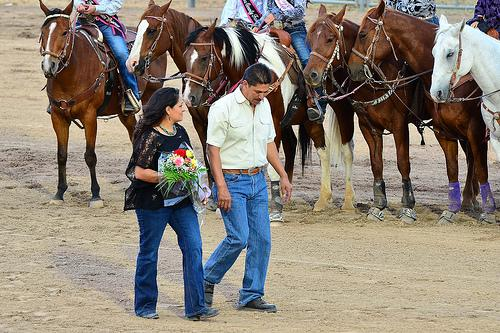Provide a brief caption for this image. A couple walking with a flower bouquet near a line of standing horses on a sandy ground. Count the number of horses in the image. There are six horses in the image. What emotions or sentiments can you identify from the image? The image evokes a sense of tranquility and harmony, as the couple and the horses are peacefully interacting in a natural environment. Describe the ground surface in the image. The ground surface is sandy and brown in color, with visible footprints and horse tracks. Mention the details of the woman's clothing and accessories. The woman is wearing a black shirt, blue jeans, a necklace, and earrings while carrying a colorful flower bouquet. Analyze the interaction between the people and the horses. The people and horses coexist peacefully, with the couple walking by the line of standing horses without interrupting or disturbing them. Describe the colors of the horses. The horses are predominantly brown and white. What are the two people in the foreground wearing, and what are they doing? A woman is wearing a black blouse and blue jeans, carrying a bouquet of flowers, while a man is wearing a white shirt, blue jeans, and a brown belt; both are walking amid horses. What types of clothing and accessories are visible on the man in the image? The man is wearing a white shirt, a brown belt, light blue jeans, and possibly black shoes. What objects are in the image? Horses, a man, a woman, a bouquet of flowers, a sash, a harness, jeans, shirt, necklace, earring, belt, and cloth on horse ankles. Identify the green tree beside the horses. There is no mention of any trees or greenery in the image. The focus is on objects and people on the dirt ground. This instruction would lead a person to search for something that is not in the image. Find the yellow bicycle leaning against one of the horses. The image is focused on horses and a couple, with no mention of bicycles or any other transportation. Asking someone to find a nonexistent bicycle would be misleading. Can you spot the child playing nearby the horses? No, it's not mentioned in the image. Notice the tent set up in the background. The image details do not contain any information about a tent or any other structure. The focus is on the people, horses, and related objects. Therefore, asking someone to find a tent would be misleading as it does not exist in the image. Can you locate the flying birds in the sky? There is no information related to birds or sky in the image. The focus is on horses, people, and objects related to them. Therefore, instructions about birds would be misleading. 